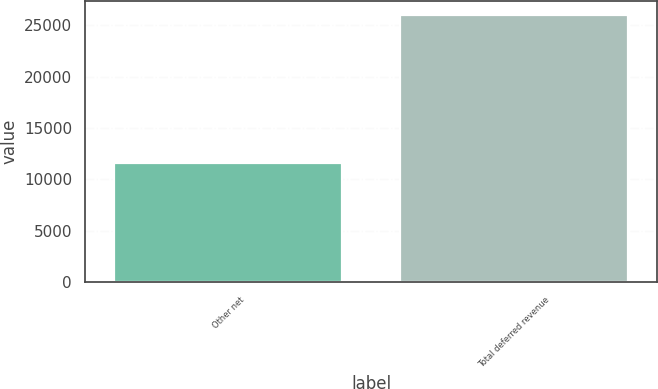Convert chart to OTSL. <chart><loc_0><loc_0><loc_500><loc_500><bar_chart><fcel>Other net<fcel>Total deferred revenue<nl><fcel>11610<fcel>26010<nl></chart> 